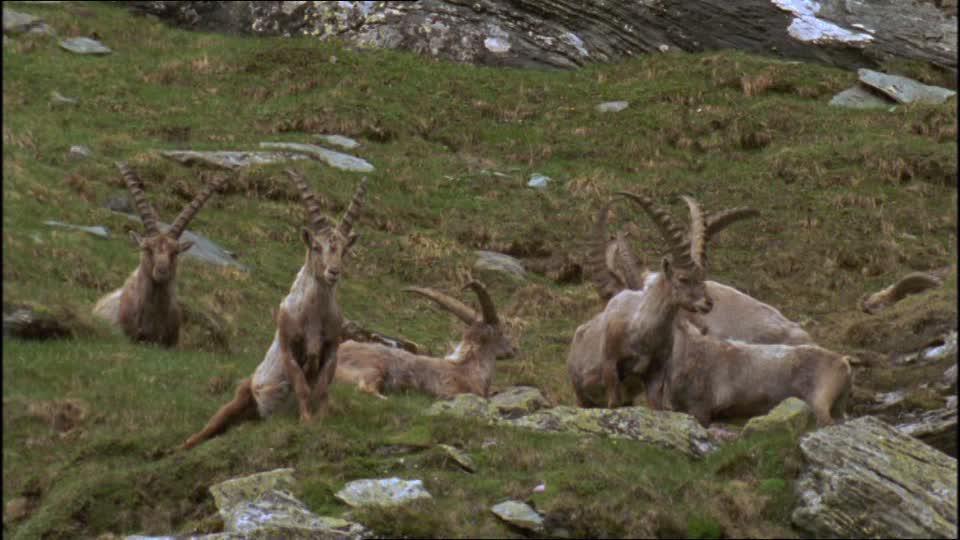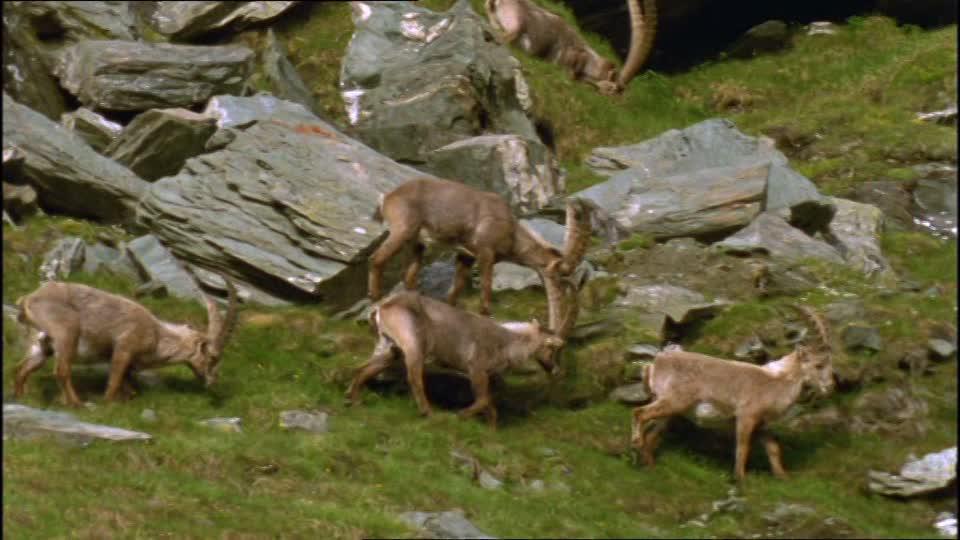The first image is the image on the left, the second image is the image on the right. Given the left and right images, does the statement "The right image includes at least twice the number of horned animals as the left image." hold true? Answer yes or no. No. The first image is the image on the left, the second image is the image on the right. Given the left and right images, does the statement "The left image shows two animals standing under a tree." hold true? Answer yes or no. No. 